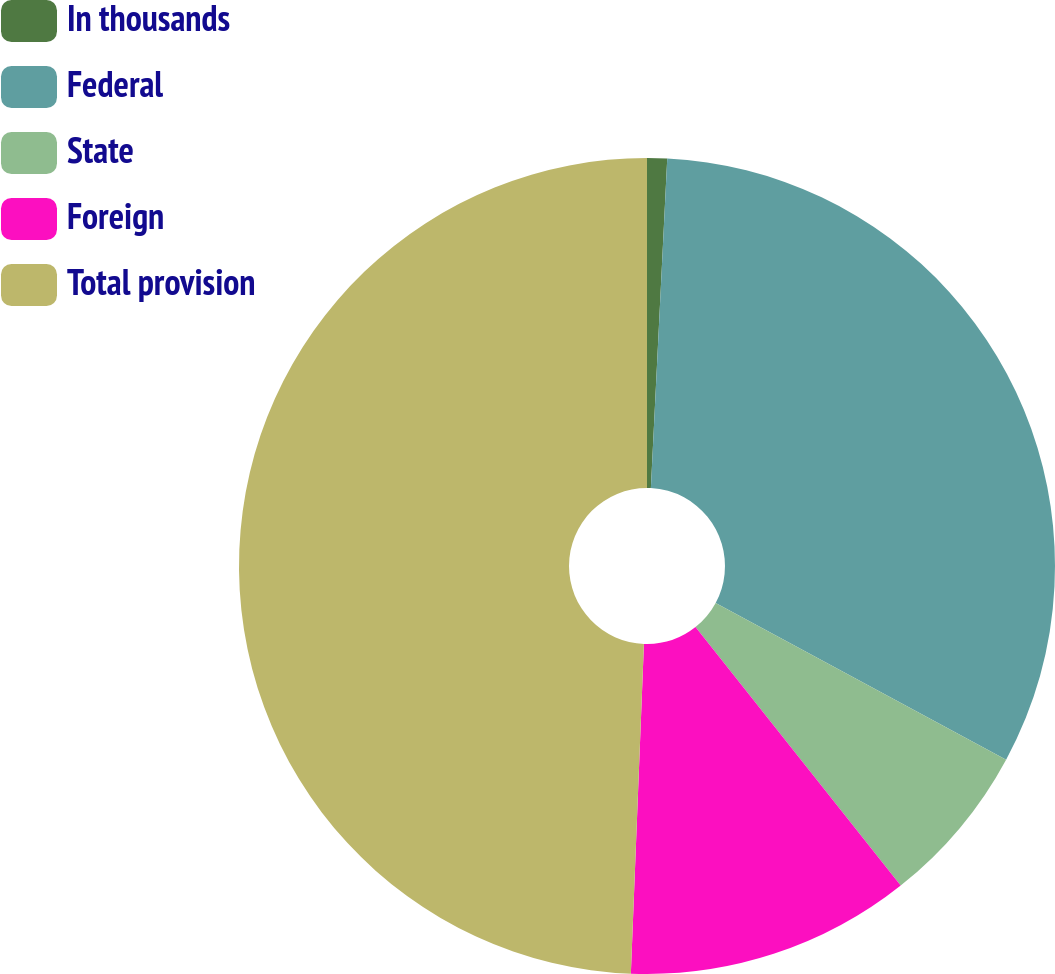Convert chart. <chart><loc_0><loc_0><loc_500><loc_500><pie_chart><fcel>In thousands<fcel>Federal<fcel>State<fcel>Foreign<fcel>Total provision<nl><fcel>0.79%<fcel>32.08%<fcel>6.45%<fcel>11.31%<fcel>49.37%<nl></chart> 